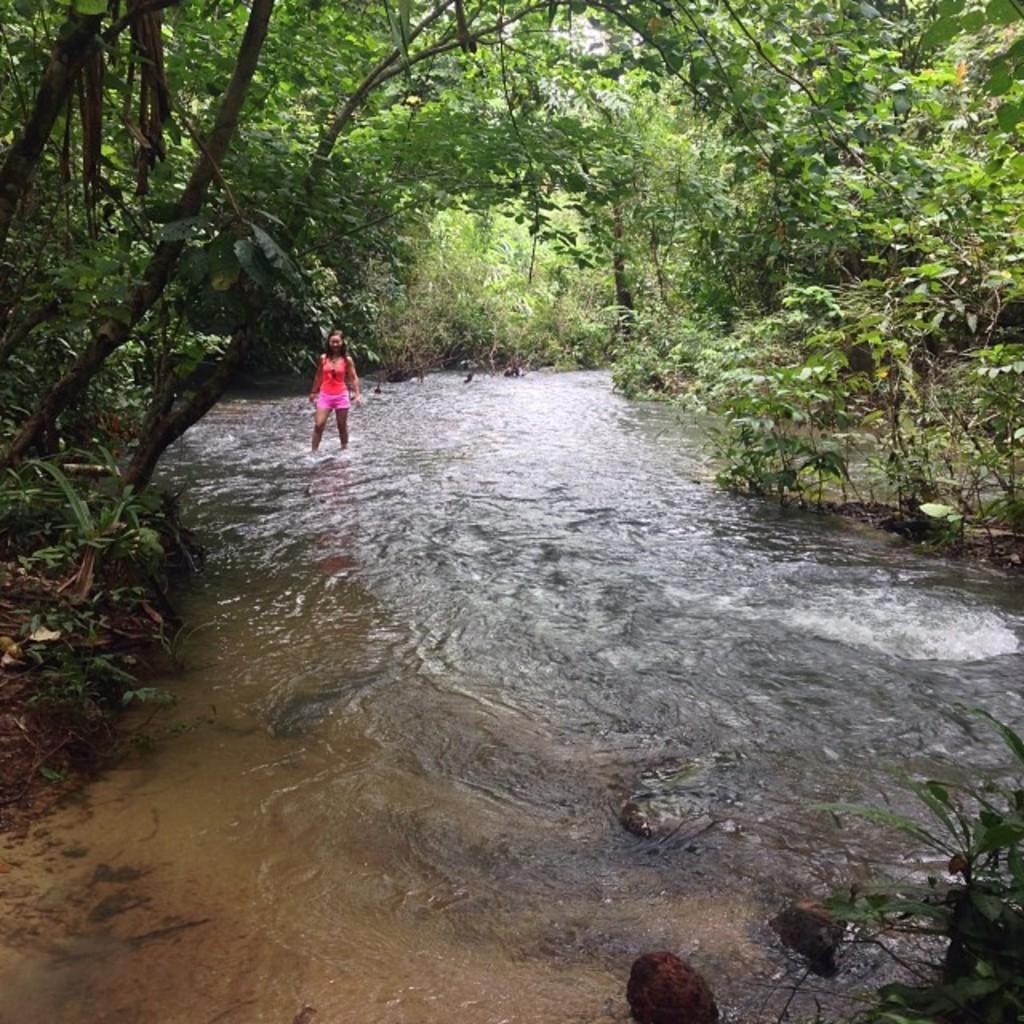Describe this image in one or two sentences. This picture shows a woman standing in the water and we see trees. 